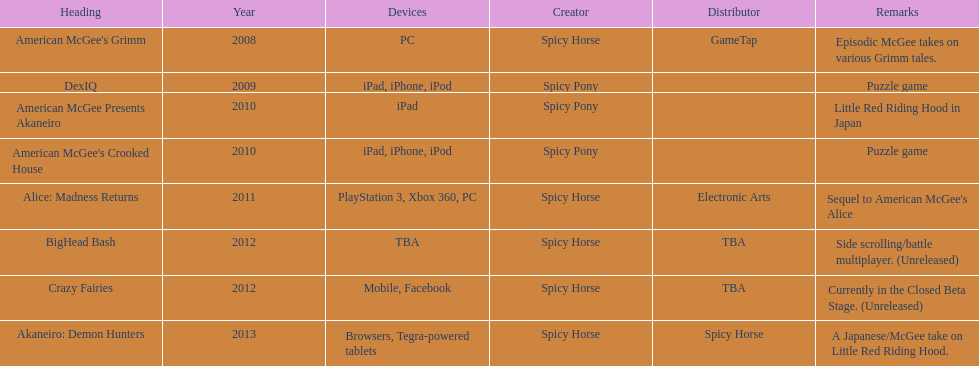Which title is for ipad but not for iphone or ipod? American McGee Presents Akaneiro. Parse the table in full. {'header': ['Heading', 'Year', 'Devices', 'Creator', 'Distributor', 'Remarks'], 'rows': [["American McGee's Grimm", '2008', 'PC', 'Spicy Horse', 'GameTap', 'Episodic McGee takes on various Grimm tales.'], ['DexIQ', '2009', 'iPad, iPhone, iPod', 'Spicy Pony', '', 'Puzzle game'], ['American McGee Presents Akaneiro', '2010', 'iPad', 'Spicy Pony', '', 'Little Red Riding Hood in Japan'], ["American McGee's Crooked House", '2010', 'iPad, iPhone, iPod', 'Spicy Pony', '', 'Puzzle game'], ['Alice: Madness Returns', '2011', 'PlayStation 3, Xbox 360, PC', 'Spicy Horse', 'Electronic Arts', "Sequel to American McGee's Alice"], ['BigHead Bash', '2012', 'TBA', 'Spicy Horse', 'TBA', 'Side scrolling/battle multiplayer. (Unreleased)'], ['Crazy Fairies', '2012', 'Mobile, Facebook', 'Spicy Horse', 'TBA', 'Currently in the Closed Beta Stage. (Unreleased)'], ['Akaneiro: Demon Hunters', '2013', 'Browsers, Tegra-powered tablets', 'Spicy Horse', 'Spicy Horse', 'A Japanese/McGee take on Little Red Riding Hood.']]} 